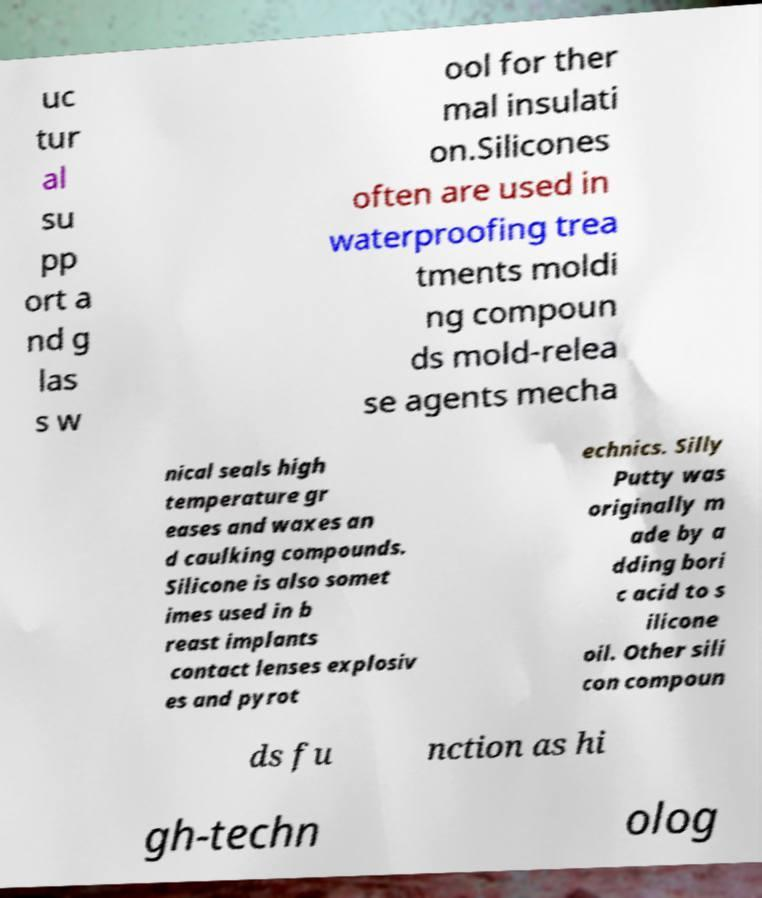Could you assist in decoding the text presented in this image and type it out clearly? uc tur al su pp ort a nd g las s w ool for ther mal insulati on.Silicones often are used in waterproofing trea tments moldi ng compoun ds mold-relea se agents mecha nical seals high temperature gr eases and waxes an d caulking compounds. Silicone is also somet imes used in b reast implants contact lenses explosiv es and pyrot echnics. Silly Putty was originally m ade by a dding bori c acid to s ilicone oil. Other sili con compoun ds fu nction as hi gh-techn olog 